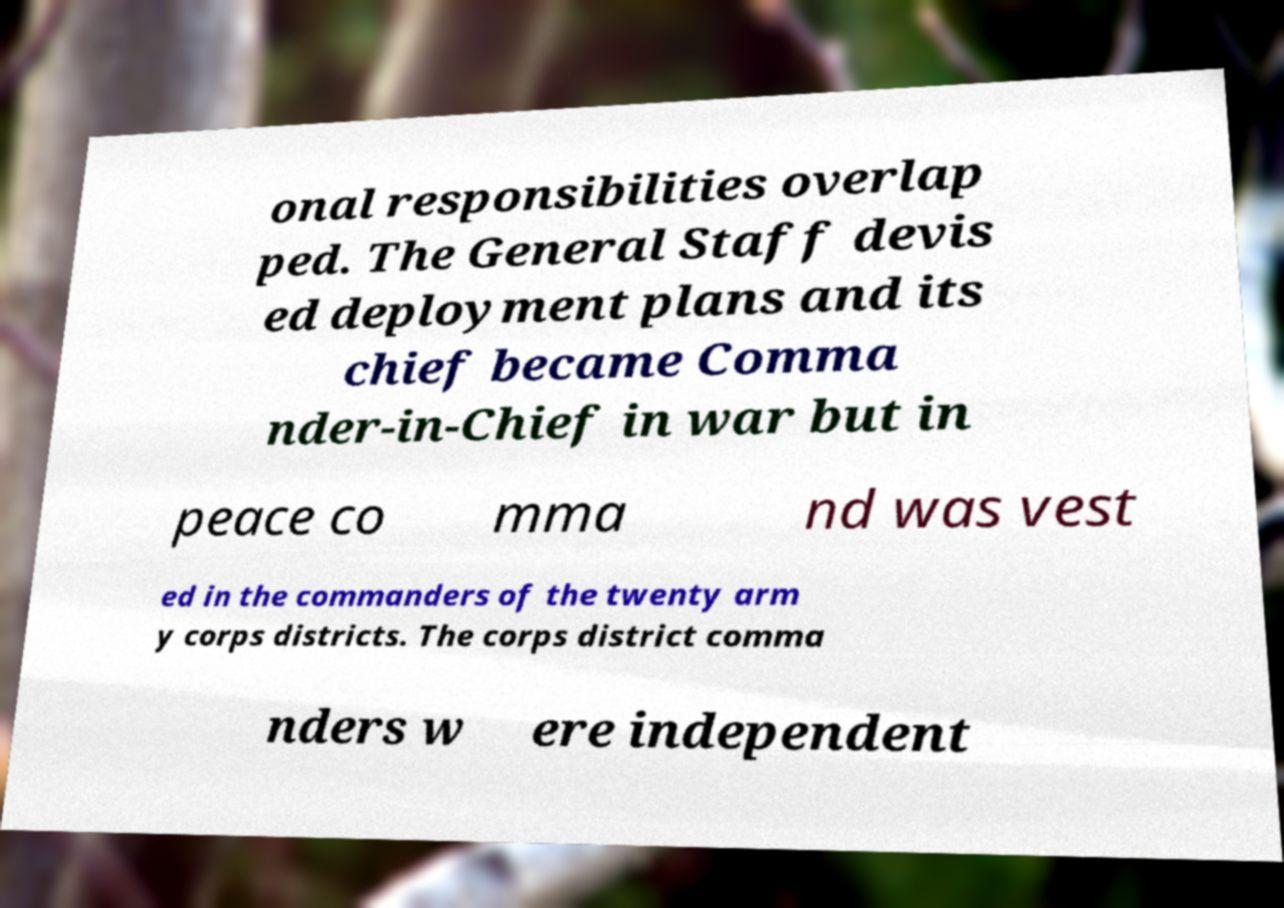Please identify and transcribe the text found in this image. onal responsibilities overlap ped. The General Staff devis ed deployment plans and its chief became Comma nder-in-Chief in war but in peace co mma nd was vest ed in the commanders of the twenty arm y corps districts. The corps district comma nders w ere independent 